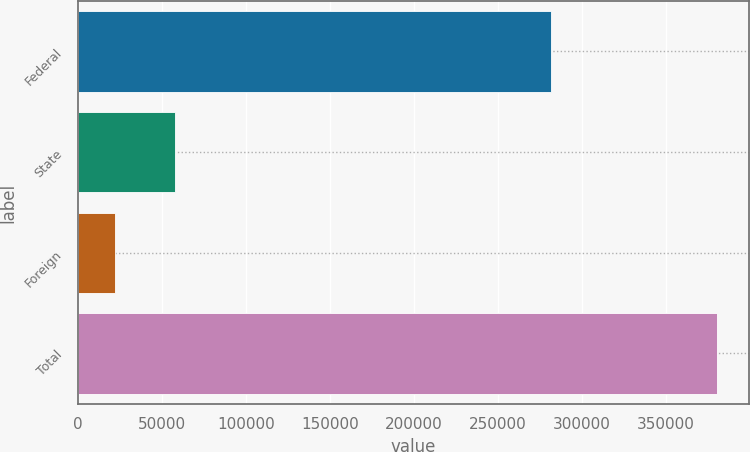Convert chart to OTSL. <chart><loc_0><loc_0><loc_500><loc_500><bar_chart><fcel>Federal<fcel>State<fcel>Foreign<fcel>Total<nl><fcel>281938<fcel>57914.9<fcel>22093<fcel>380312<nl></chart> 